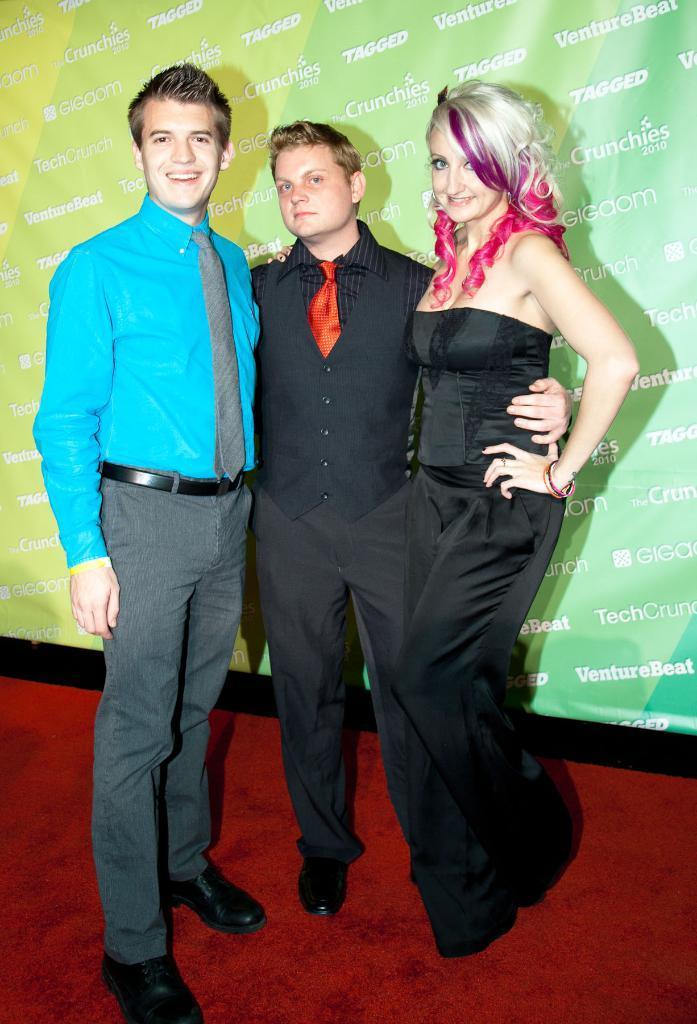How many people are in the image? There are three people in the image: two men and one woman. What are the people standing on in the image? They are standing on a red carpet. What else can be seen in the image besides the people? There is a board with text in the image. How many beds are visible in the image? There are no beds present in the image. Can you hear any sound coming from the image? The image is silent, so there is no sound to be heard. 